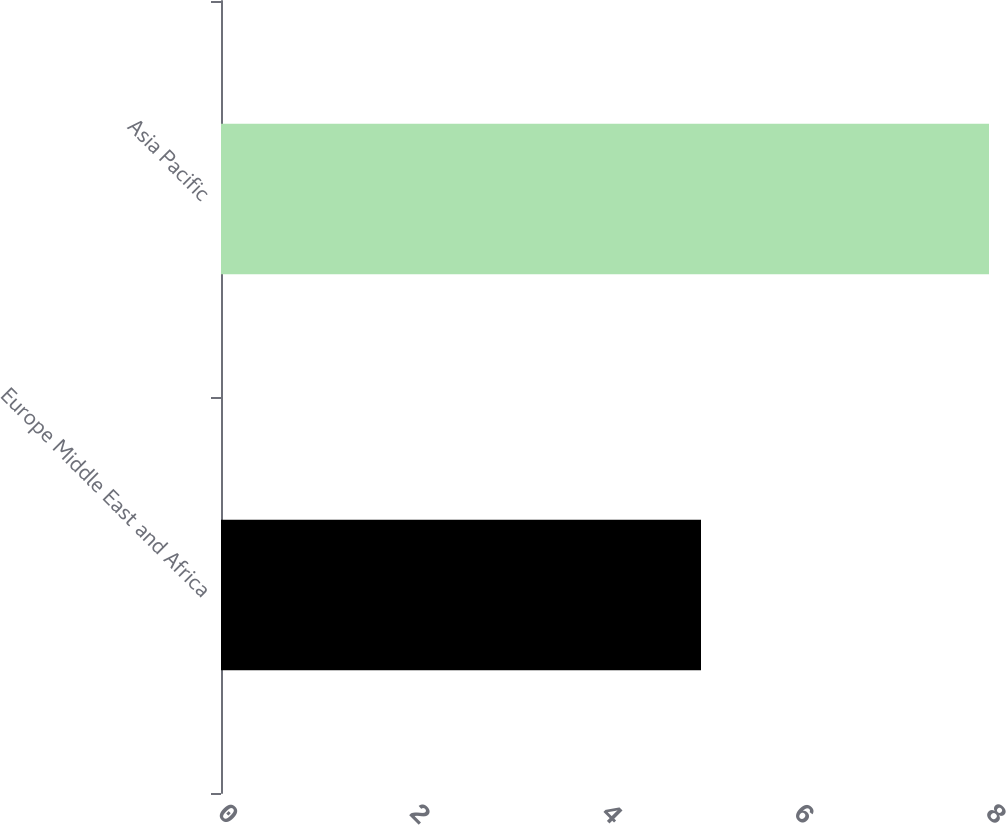<chart> <loc_0><loc_0><loc_500><loc_500><bar_chart><fcel>Europe Middle East and Africa<fcel>Asia Pacific<nl><fcel>5<fcel>8<nl></chart> 